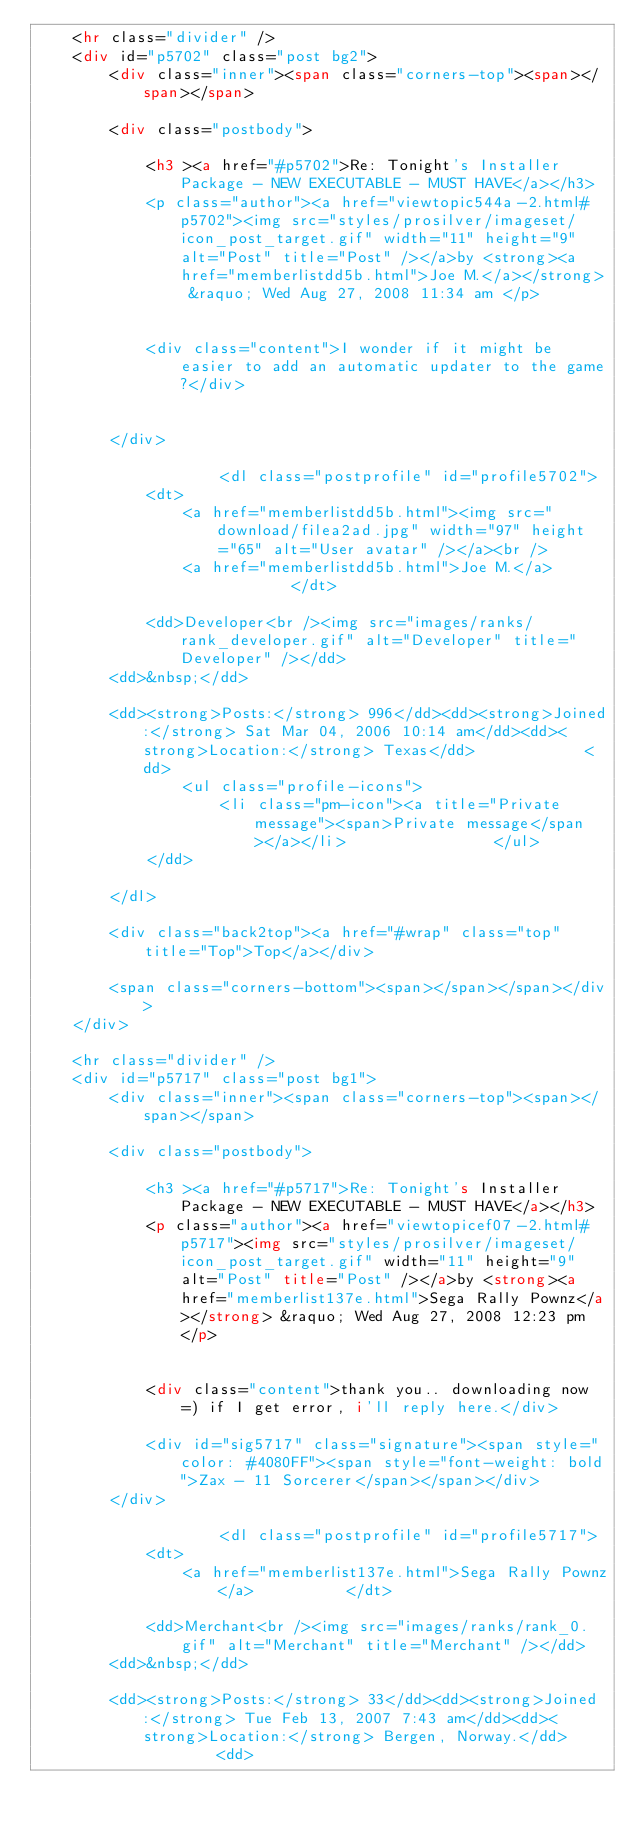Convert code to text. <code><loc_0><loc_0><loc_500><loc_500><_HTML_>	<hr class="divider" />
	<div id="p5702" class="post bg2">
		<div class="inner"><span class="corners-top"><span></span></span>

		<div class="postbody">
			
			<h3 ><a href="#p5702">Re: Tonight's Installer Package - NEW EXECUTABLE - MUST HAVE</a></h3>
			<p class="author"><a href="viewtopic544a-2.html#p5702"><img src="styles/prosilver/imageset/icon_post_target.gif" width="11" height="9" alt="Post" title="Post" /></a>by <strong><a href="memberlistdd5b.html">Joe M.</a></strong> &raquo; Wed Aug 27, 2008 11:34 am </p>

			
			<div class="content">I wonder if it might be easier to add an automatic updater to the game?</div>

			
		</div>

					<dl class="postprofile" id="profile5702">
			<dt>
				<a href="memberlistdd5b.html"><img src="download/filea2ad.jpg" width="97" height="65" alt="User avatar" /></a><br />
				<a href="memberlistdd5b.html">Joe M.</a>			</dt>

			<dd>Developer<br /><img src="images/ranks/rank_developer.gif" alt="Developer" title="Developer" /></dd>
		<dd>&nbsp;</dd>

		<dd><strong>Posts:</strong> 996</dd><dd><strong>Joined:</strong> Sat Mar 04, 2006 10:14 am</dd><dd><strong>Location:</strong> Texas</dd>			<dd>
				<ul class="profile-icons">
					<li class="pm-icon"><a title="Private message"><span>Private message</span></a></li>				</ul>
			</dd>
		
		</dl>
	
		<div class="back2top"><a href="#wrap" class="top" title="Top">Top</a></div>

		<span class="corners-bottom"><span></span></span></div>
	</div>

	<hr class="divider" />
	<div id="p5717" class="post bg1">
		<div class="inner"><span class="corners-top"><span></span></span>

		<div class="postbody">
			
			<h3 ><a href="#p5717">Re: Tonight's Installer Package - NEW EXECUTABLE - MUST HAVE</a></h3>
			<p class="author"><a href="viewtopicef07-2.html#p5717"><img src="styles/prosilver/imageset/icon_post_target.gif" width="11" height="9" alt="Post" title="Post" /></a>by <strong><a href="memberlist137e.html">Sega Rally Pownz</a></strong> &raquo; Wed Aug 27, 2008 12:23 pm </p>

			
			<div class="content">thank you.. downloading now =) if I get error, i'll reply here.</div>

			<div id="sig5717" class="signature"><span style="color: #4080FF"><span style="font-weight: bold">Zax - 11 Sorcerer</span></span></div>
		</div>

					<dl class="postprofile" id="profile5717">
			<dt>
				<a href="memberlist137e.html">Sega Rally Pownz</a>			</dt>

			<dd>Merchant<br /><img src="images/ranks/rank_0.gif" alt="Merchant" title="Merchant" /></dd>
		<dd>&nbsp;</dd>

		<dd><strong>Posts:</strong> 33</dd><dd><strong>Joined:</strong> Tue Feb 13, 2007 7:43 am</dd><dd><strong>Location:</strong> Bergen, Norway.</dd>			<dd></code> 